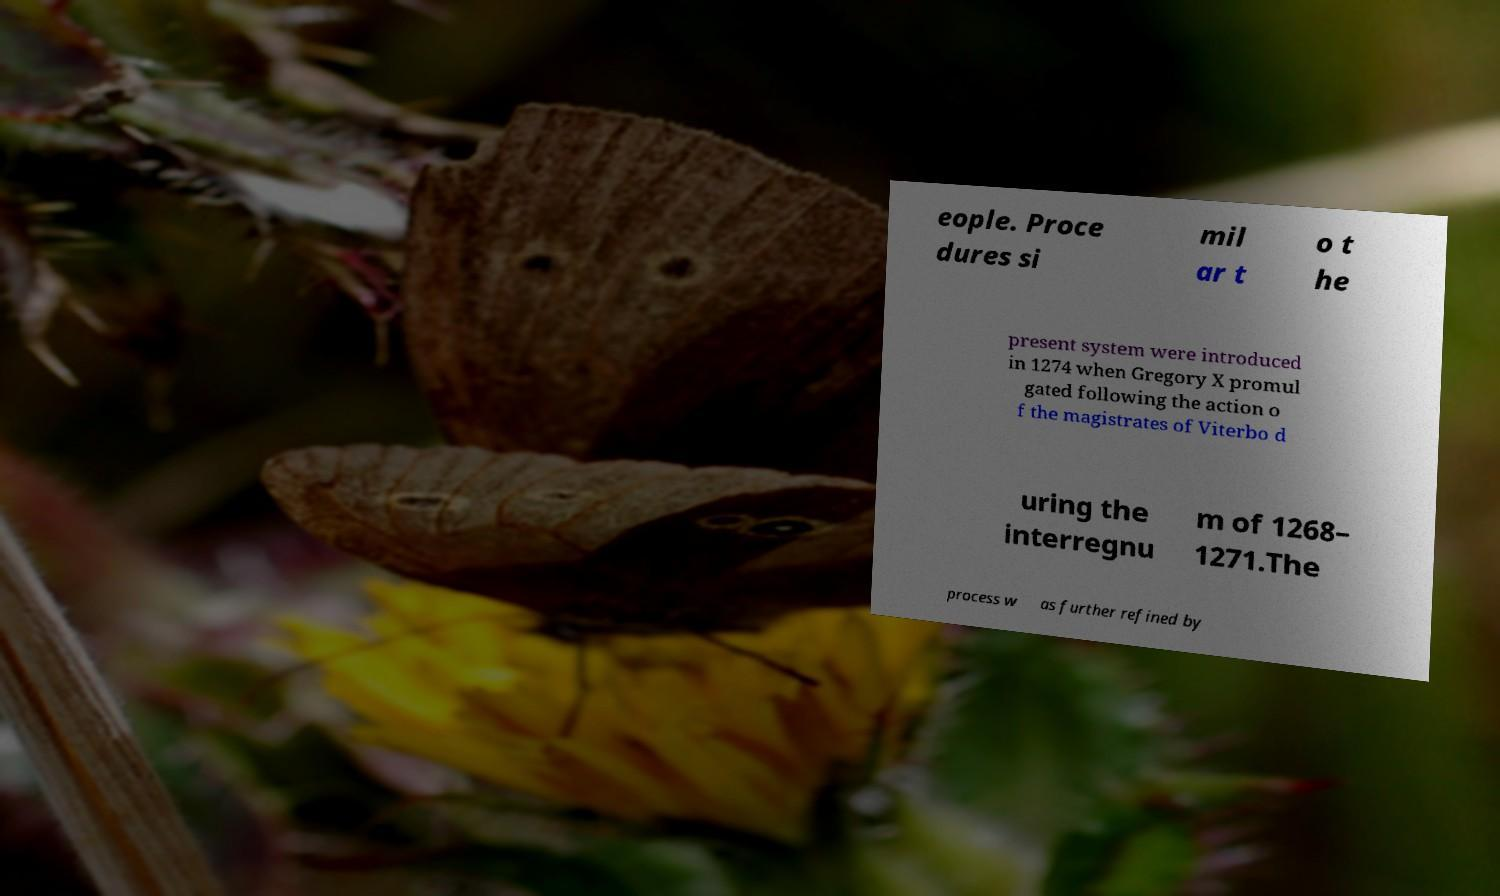Can you accurately transcribe the text from the provided image for me? eople. Proce dures si mil ar t o t he present system were introduced in 1274 when Gregory X promul gated following the action o f the magistrates of Viterbo d uring the interregnu m of 1268– 1271.The process w as further refined by 